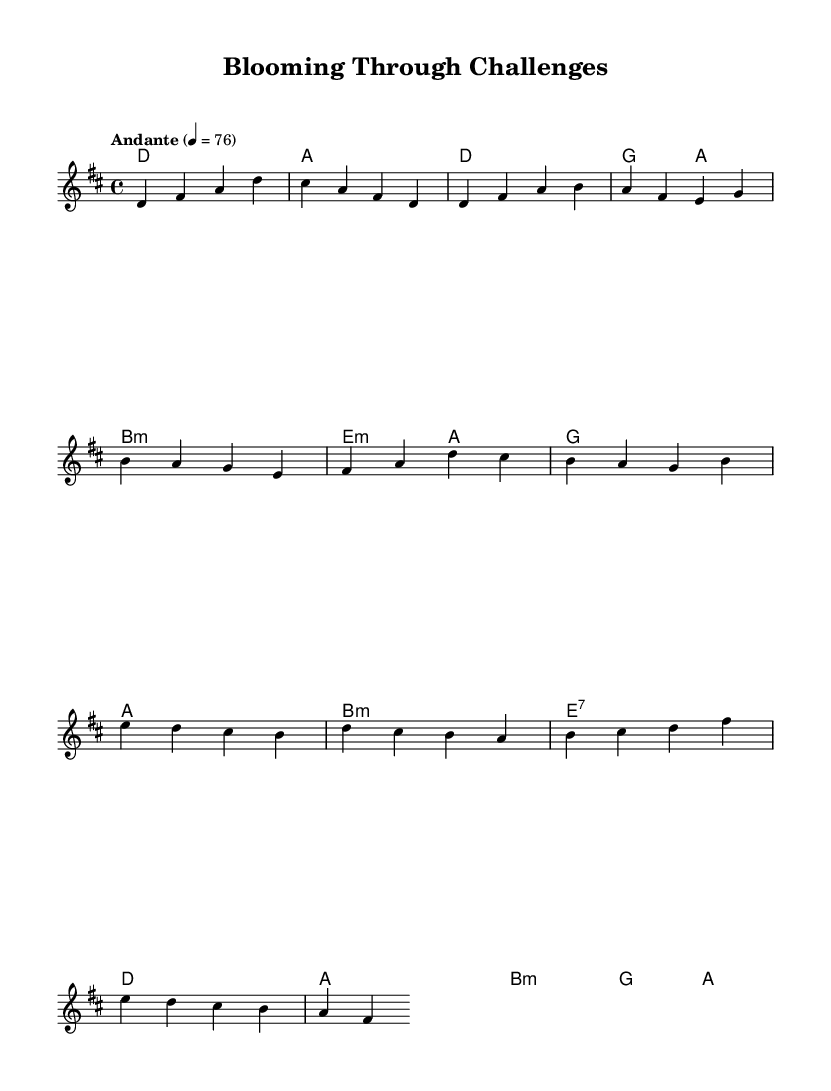What is the key signature of this music? The key signature is indicated in the global section where it shows "d major," which means it has two sharps (F# and C#).
Answer: D major What is the time signature of this piece? The time signature is found in the global section as "4/4," indicating that there are four beats in each measure and the quarter note gets one beat.
Answer: 4/4 What is the tempo marking for this music? The tempo marking is included in the global section as "Andante," with a metronome marking of 76, suggesting a slow, walking pace.
Answer: Andante How many measures are present in the chorus section? By counting the measures in the chorus part of the melody, we see it consists of four measures. The measures are separated by vertical lines in sheet music.
Answer: Four What is the chord used in the pre-chorus first measure? In the harmonies section under pre-chorus, the first chord listed is "G," which indicates the harmonic backdrop for the melody.
Answer: G What emotional theme does the title suggest? The title "Blooming Through Challenges" implies a journey of personal growth, resonating with listeners who appreciate themes of resilience and success often found in K-Pop ballads.
Answer: Personal growth Which musical section typically highlights the emotion of a song? In this type of music, the chorus generally emphasizes the emotional high point, showcasing the most memorable and impactful lyrics and melodies.
Answer: Chorus 